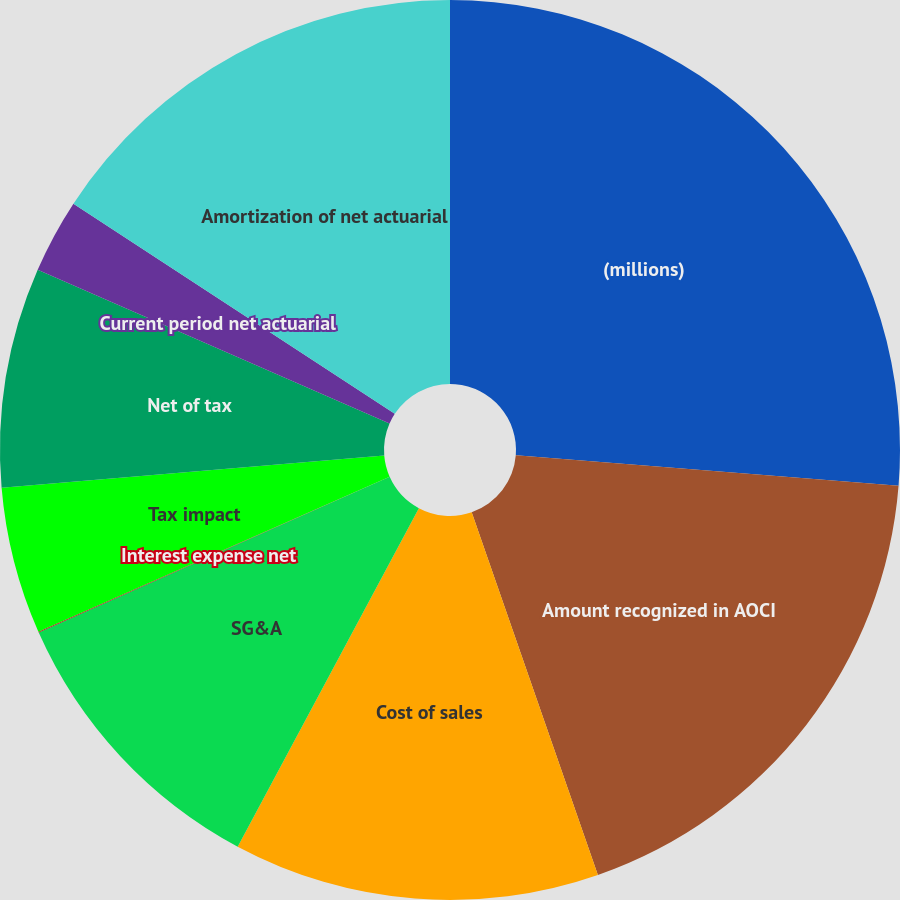Convert chart. <chart><loc_0><loc_0><loc_500><loc_500><pie_chart><fcel>(millions)<fcel>Amount recognized in AOCI<fcel>Cost of sales<fcel>SG&A<fcel>Interest expense net<fcel>Tax impact<fcel>Net of tax<fcel>Current period net actuarial<fcel>Amortization of net actuarial<nl><fcel>26.27%<fcel>18.4%<fcel>13.15%<fcel>10.53%<fcel>0.03%<fcel>5.28%<fcel>7.9%<fcel>2.66%<fcel>15.78%<nl></chart> 